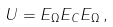Convert formula to latex. <formula><loc_0><loc_0><loc_500><loc_500>U = E _ { \Omega } E _ { C } E _ { \Omega } \, ,</formula> 